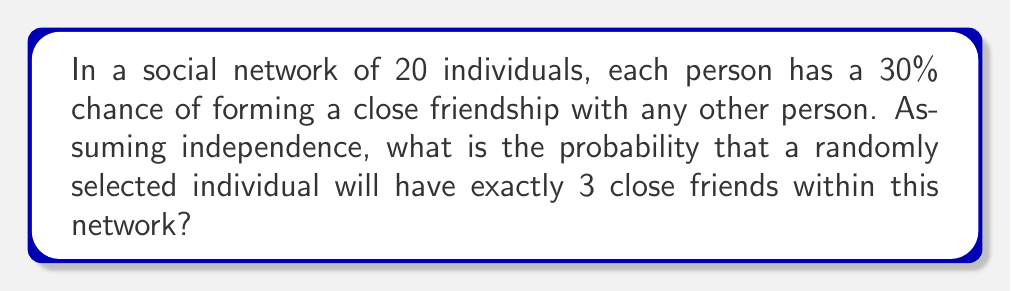Teach me how to tackle this problem. To solve this problem, we can use the binomial probability distribution. Let's break it down step-by-step:

1) We have a binomial situation because:
   - There are fixed number of trials (19 potential friendships)
   - Each trial has two possible outcomes (form a close friendship or not)
   - The probability of success (forming a close friendship) is constant (30% or 0.3)
   - The trials are independent

2) The binomial probability formula is:

   $$P(X=k) = \binom{n}{k} p^k (1-p)^{n-k}$$

   Where:
   $n$ = number of trials
   $k$ = number of successes
   $p$ = probability of success on each trial

3) In our case:
   $n = 19$ (potential friendships with other 19 people)
   $k = 3$ (we want exactly 3 close friends)
   $p = 0.3$ (30% chance of forming a close friendship)

4) Let's substitute these values:

   $$P(X=3) = \binom{19}{3} (0.3)^3 (1-0.3)^{19-3}$$

5) Simplify:
   $$P(X=3) = \binom{19}{3} (0.3)^3 (0.7)^{16}$$

6) Calculate the binomial coefficient:
   $$\binom{19}{3} = \frac{19!}{3!(19-3)!} = \frac{19!}{3!16!} = 969$$

7) Now our equation looks like:
   $$P(X=3) = 969 \times (0.3)^3 \times (0.7)^{16}$$

8) Calculate:
   $$P(X=3) = 969 \times 0.027 \times 0.0138 = 0.3613$$

9) Therefore, the probability is approximately 0.3613 or 36.13%
Answer: 0.3613 